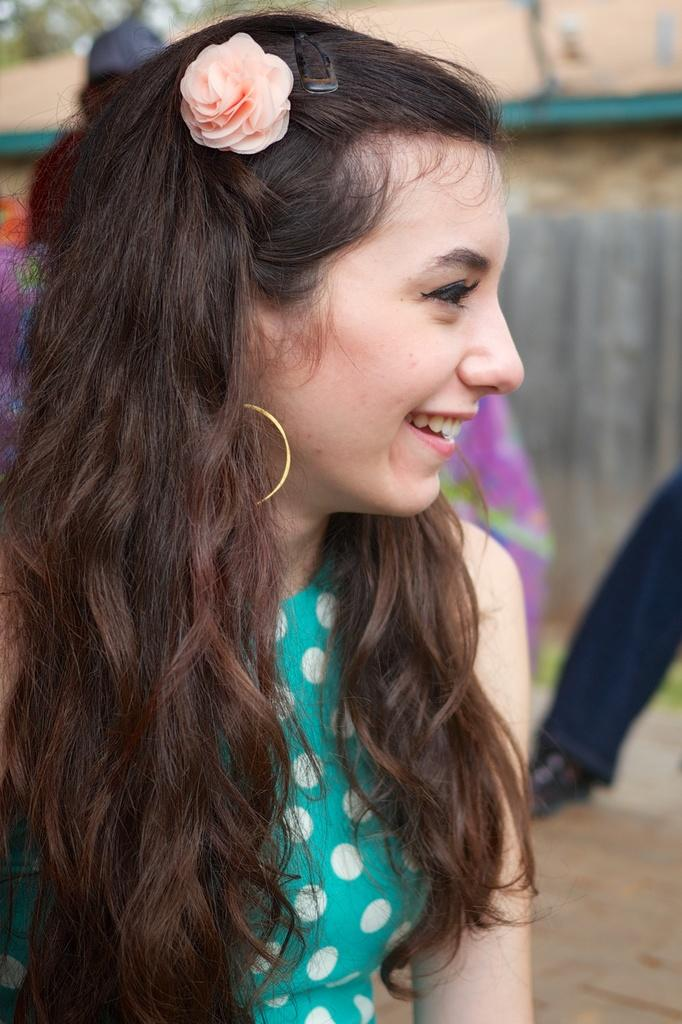What is the woman in the image doing? The woman is seated in the image. What expression does the woman have on her face? The woman has a smile on her face. What can be seen in the woman's hair? The woman has a rose flower in her hair. How many people are visible in the image? There are people visible in the image. What is one feature of the background in the image? There is a wall in the image. What type of animal can be seen swimming in the image? There is no animal visible in the image, let alone swimming. 